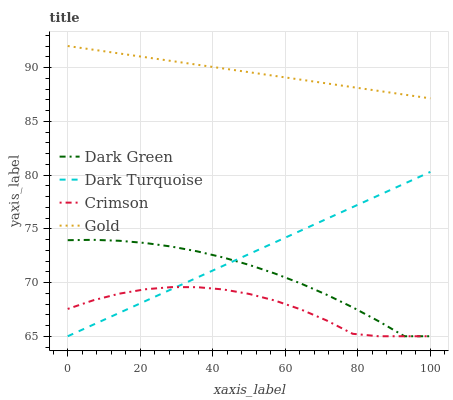Does Dark Turquoise have the minimum area under the curve?
Answer yes or no. No. Does Dark Turquoise have the maximum area under the curve?
Answer yes or no. No. Is Gold the smoothest?
Answer yes or no. No. Is Gold the roughest?
Answer yes or no. No. Does Gold have the lowest value?
Answer yes or no. No. Does Dark Turquoise have the highest value?
Answer yes or no. No. Is Dark Green less than Gold?
Answer yes or no. Yes. Is Gold greater than Dark Turquoise?
Answer yes or no. Yes. Does Dark Green intersect Gold?
Answer yes or no. No. 